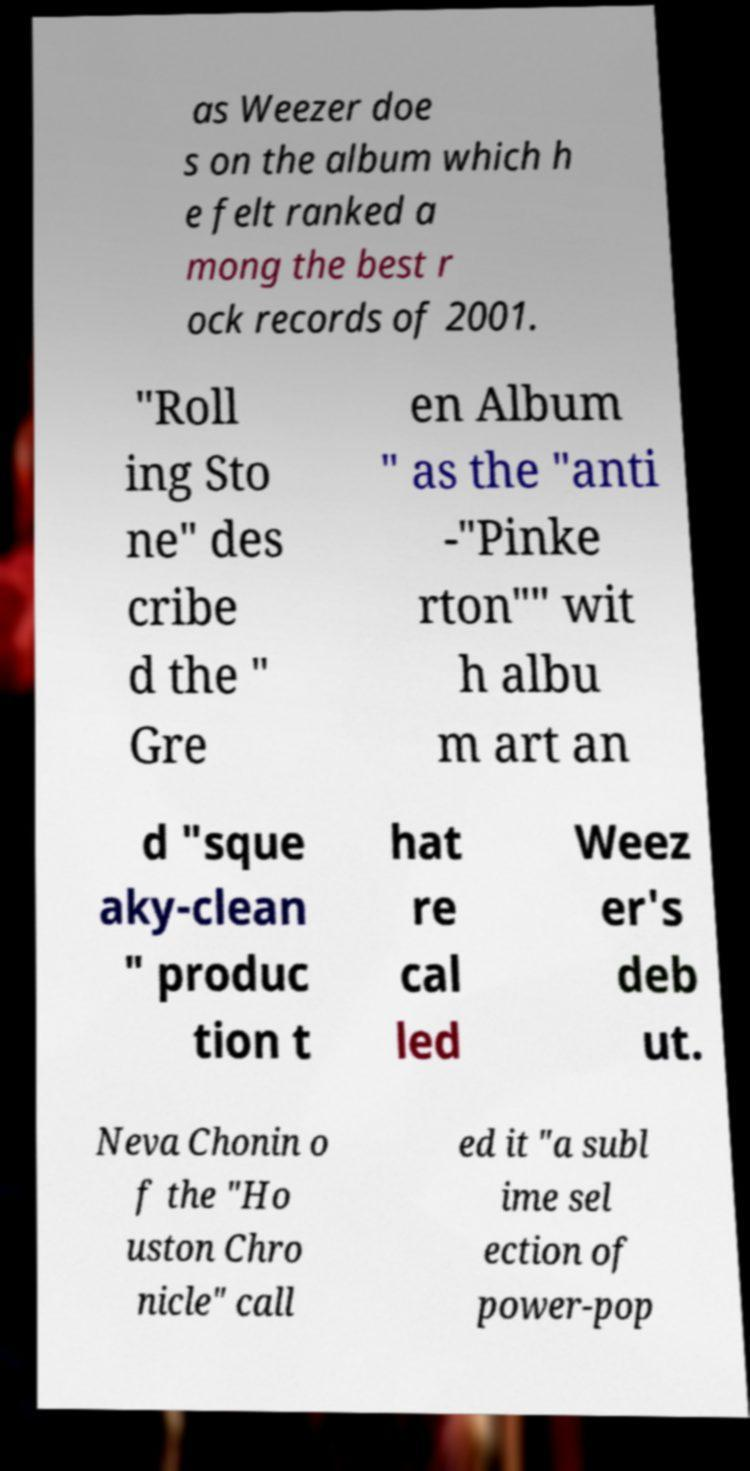Please read and relay the text visible in this image. What does it say? as Weezer doe s on the album which h e felt ranked a mong the best r ock records of 2001. "Roll ing Sto ne" des cribe d the " Gre en Album " as the "anti -"Pinke rton"" wit h albu m art an d "sque aky-clean " produc tion t hat re cal led Weez er's deb ut. Neva Chonin o f the "Ho uston Chro nicle" call ed it "a subl ime sel ection of power-pop 